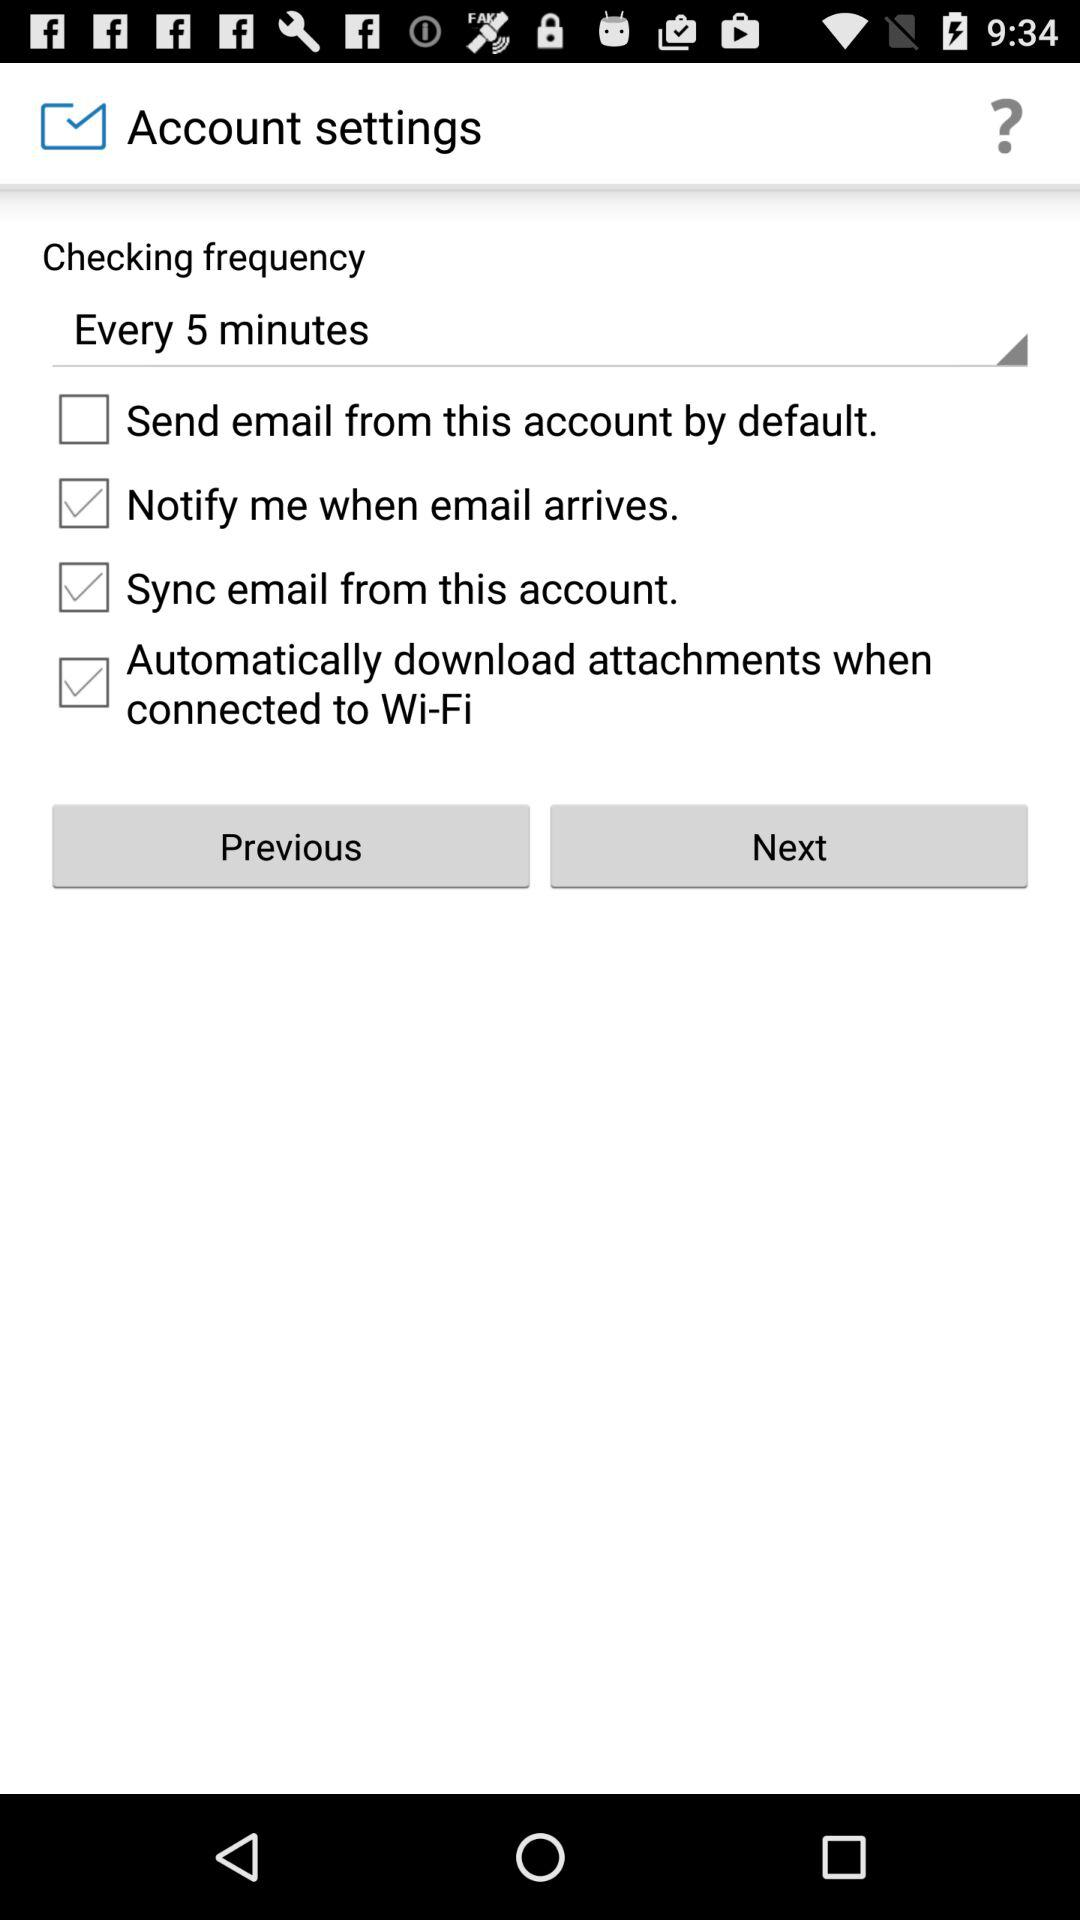Which option is unchecked? The unchecked option is "Send email from this account by default". 